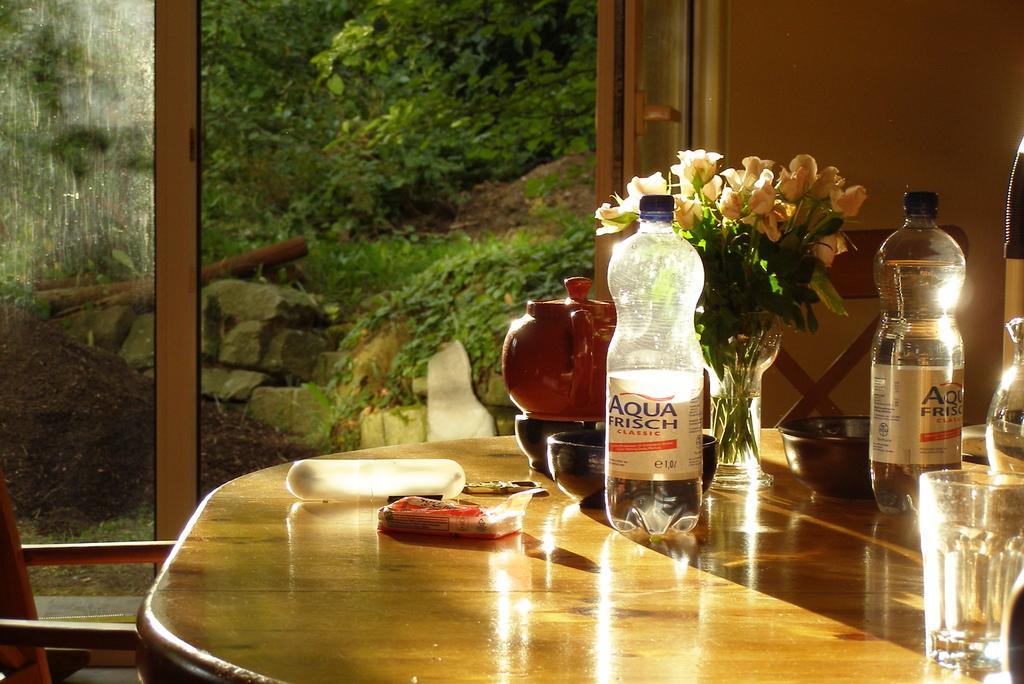Please provide a concise description of this image. In this image I can see two bottles, a flower pot, a jug on the table and the flowers are in cream color. Background I can see few windows, trees in green color and I can also see few rocks. 